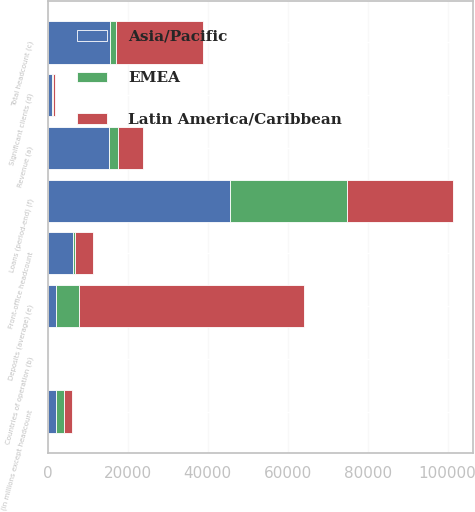Convert chart to OTSL. <chart><loc_0><loc_0><loc_500><loc_500><stacked_bar_chart><ecel><fcel>(in millions except headcount<fcel>Revenue (a)<fcel>Countries of operation (b)<fcel>Total headcount (c)<fcel>Front-office headcount<fcel>Significant clients (d)<fcel>Deposits (average) (e)<fcel>Loans (period-end) (f)<nl><fcel>Asia/Pacific<fcel>2013<fcel>15441<fcel>33<fcel>15560<fcel>6285<fcel>1071<fcel>2233<fcel>45571<nl><fcel>Latin America/Caribbean<fcel>2013<fcel>6138<fcel>17<fcel>21699<fcel>4353<fcel>498<fcel>56440<fcel>26560<nl><fcel>EMEA<fcel>2013<fcel>2233<fcel>9<fcel>1495<fcel>655<fcel>177<fcel>5546<fcel>29214<nl></chart> 